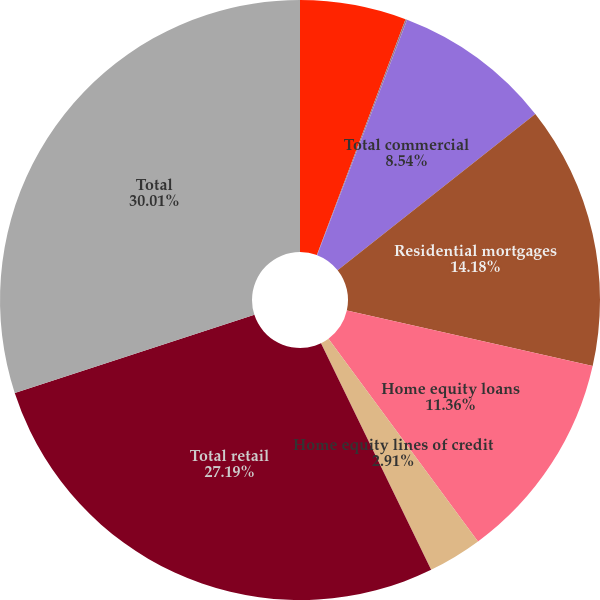<chart> <loc_0><loc_0><loc_500><loc_500><pie_chart><fcel>Commercial<fcel>Commercial real estate<fcel>Total commercial<fcel>Residential mortgages<fcel>Home equity loans<fcel>Home equity lines of credit<fcel>Total retail<fcel>Total<nl><fcel>5.72%<fcel>0.09%<fcel>8.54%<fcel>14.18%<fcel>11.36%<fcel>2.91%<fcel>27.19%<fcel>30.01%<nl></chart> 